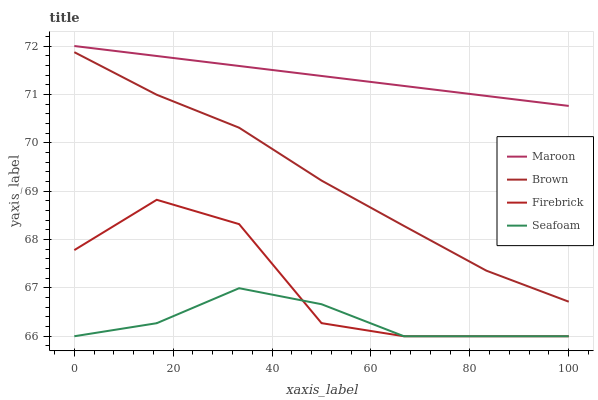Does Seafoam have the minimum area under the curve?
Answer yes or no. Yes. Does Maroon have the maximum area under the curve?
Answer yes or no. Yes. Does Firebrick have the minimum area under the curve?
Answer yes or no. No. Does Firebrick have the maximum area under the curve?
Answer yes or no. No. Is Maroon the smoothest?
Answer yes or no. Yes. Is Firebrick the roughest?
Answer yes or no. Yes. Is Seafoam the smoothest?
Answer yes or no. No. Is Seafoam the roughest?
Answer yes or no. No. Does Firebrick have the lowest value?
Answer yes or no. Yes. Does Maroon have the lowest value?
Answer yes or no. No. Does Maroon have the highest value?
Answer yes or no. Yes. Does Firebrick have the highest value?
Answer yes or no. No. Is Firebrick less than Brown?
Answer yes or no. Yes. Is Brown greater than Firebrick?
Answer yes or no. Yes. Does Firebrick intersect Seafoam?
Answer yes or no. Yes. Is Firebrick less than Seafoam?
Answer yes or no. No. Is Firebrick greater than Seafoam?
Answer yes or no. No. Does Firebrick intersect Brown?
Answer yes or no. No. 